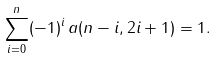Convert formula to latex. <formula><loc_0><loc_0><loc_500><loc_500>\sum _ { i = 0 } ^ { n } ( - 1 ) ^ { i } \, a ( n - i , 2 i + 1 ) = 1 .</formula> 